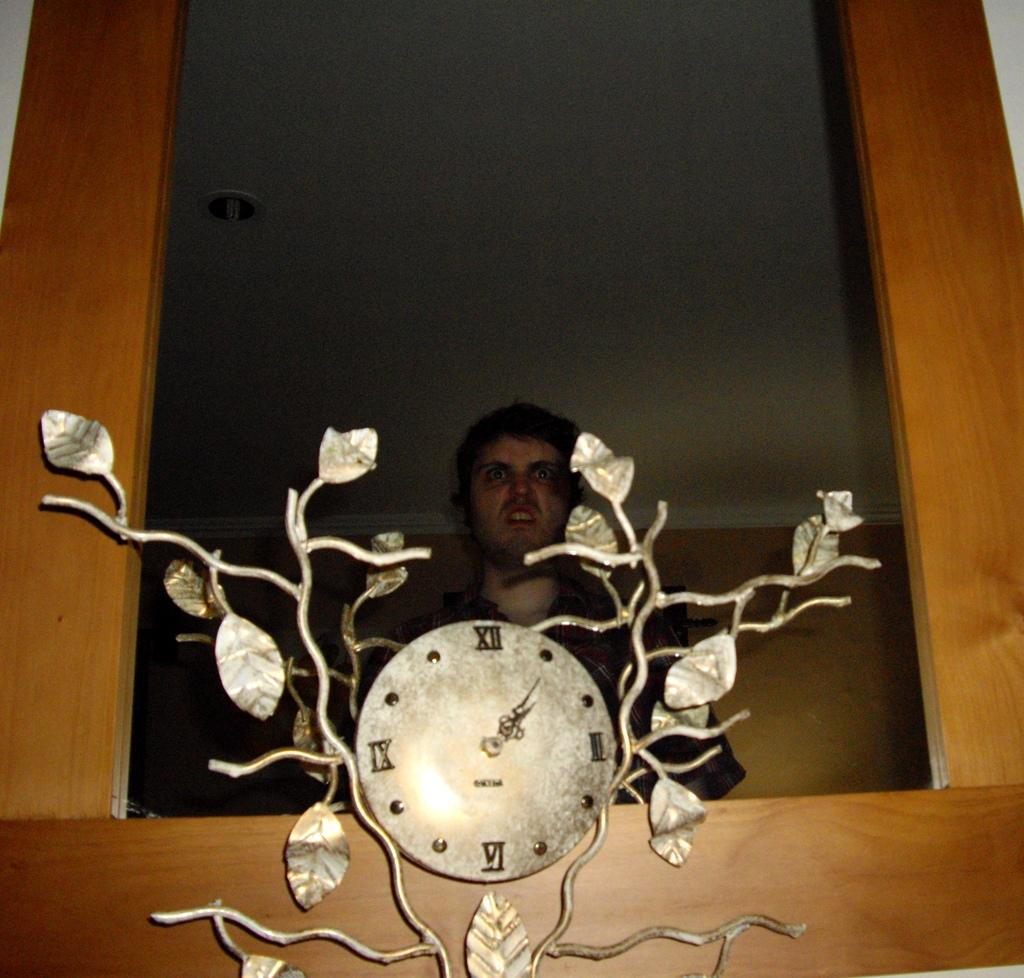<image>
Offer a succinct explanation of the picture presented. a man is looking in a mirror and a clock in front of it says 1:05 